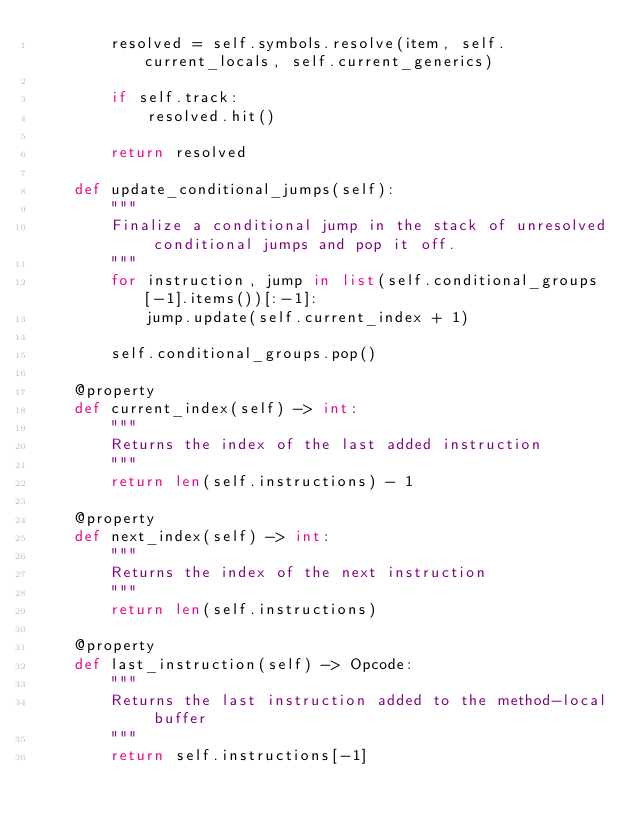<code> <loc_0><loc_0><loc_500><loc_500><_Python_>        resolved = self.symbols.resolve(item, self.current_locals, self.current_generics)

        if self.track:
            resolved.hit()

        return resolved

    def update_conditional_jumps(self):
        """
        Finalize a conditional jump in the stack of unresolved conditional jumps and pop it off.
        """
        for instruction, jump in list(self.conditional_groups[-1].items())[:-1]:
            jump.update(self.current_index + 1)

        self.conditional_groups.pop()

    @property
    def current_index(self) -> int:
        """
        Returns the index of the last added instruction
        """
        return len(self.instructions) - 1

    @property
    def next_index(self) -> int:
        """
        Returns the index of the next instruction
        """
        return len(self.instructions)

    @property
    def last_instruction(self) -> Opcode:
        """
        Returns the last instruction added to the method-local buffer
        """
        return self.instructions[-1]

</code> 